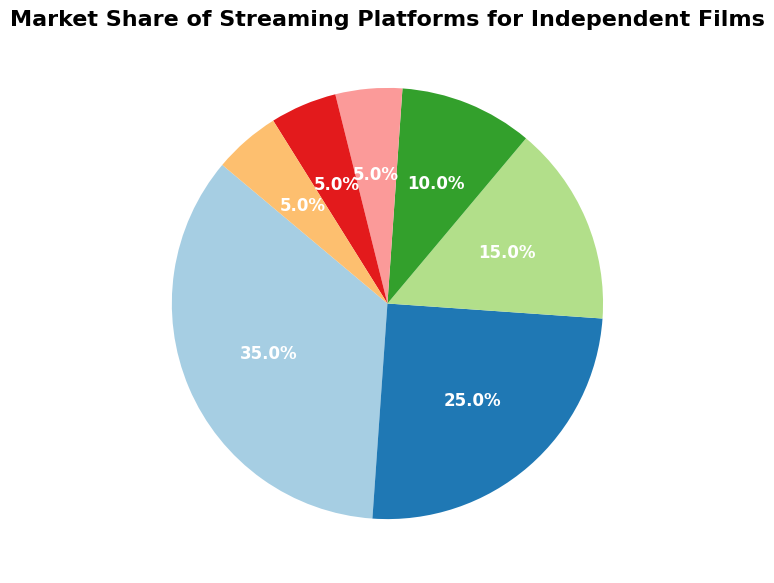Which platform holds the largest market share for independent films? By looking at the pie chart, the segment for Netflix appears the largest and is labeled with a market share of 35%.
Answer: Netflix What is the combined market share of Hulu and Disney+? The pie chart shows that Hulu has a market share of 15% and Disney+ has 10%. Adding those together: 15% + 10% = 25%.
Answer: 25% Which platform has the smallest market share, and what is it? The chart reveals that Apple TV+, HBO Max, and "Other" each have the smallest market share, all labeled with 5%.
Answer: Apple TV+, HBO Max, and Other; 5% How much larger is Netflix’s market share compared to Amazon Prime Video’s? Netflix has a market share of 35%, and Amazon Prime Video has 25%. The difference is 35% - 25% = 10%.
Answer: 10% What proportion of the total market share is held by platforms with a share of 5% or less? From the chart, platforms with a share of 5% are Apple TV+, HBO Max, and Other. Summing these: 5% + 5% + 5% = 15%.
Answer: 15% Which segment is visually represented by a green color? The segments' colors are based on the Pie chart. To determine the specific segment, one needs to match the green color visually to the labeled sections. This requires observing the chart directly.
Answer: (Varies by observation) Is the combined market share of Amazon Prime Video and Apple TV+ greater than Netflix alone? Amazon Prime Video has 25% and Apple TV+ has 5%. Adding them together: 25% + 5% = 30%. Netflix has 35%, which is greater than 30%.
Answer: No How does the market share of Hulu compare to the total of all other platforms combined except Netflix? Hulu has 15%. The total of other platforms except Netflix is Amazon Prime Video (25%) + Disney+ (10%) + Apple TV+ (5%) + HBO Max (5%) + Other (5%) = 50%. Hulu's 15% is less than 50%.
Answer: Less What fraction of the market share is contributed by Disney+? The pie chart indicates Disney+ has a 10% share. To convert this into a fraction of the total market share (assumed to be 100% from the chart), 10% of 100% is 10/100, which simplifies to 1/10.
Answer: 1/10 How much greater is Netflix’s market share compared to the smallest platform? Netflix has a market share of 35%. The smallest market shares are 5% each (Apple TV+, HBO Max, and Other). The difference is 35% - 5% = 30%.
Answer: 30% 